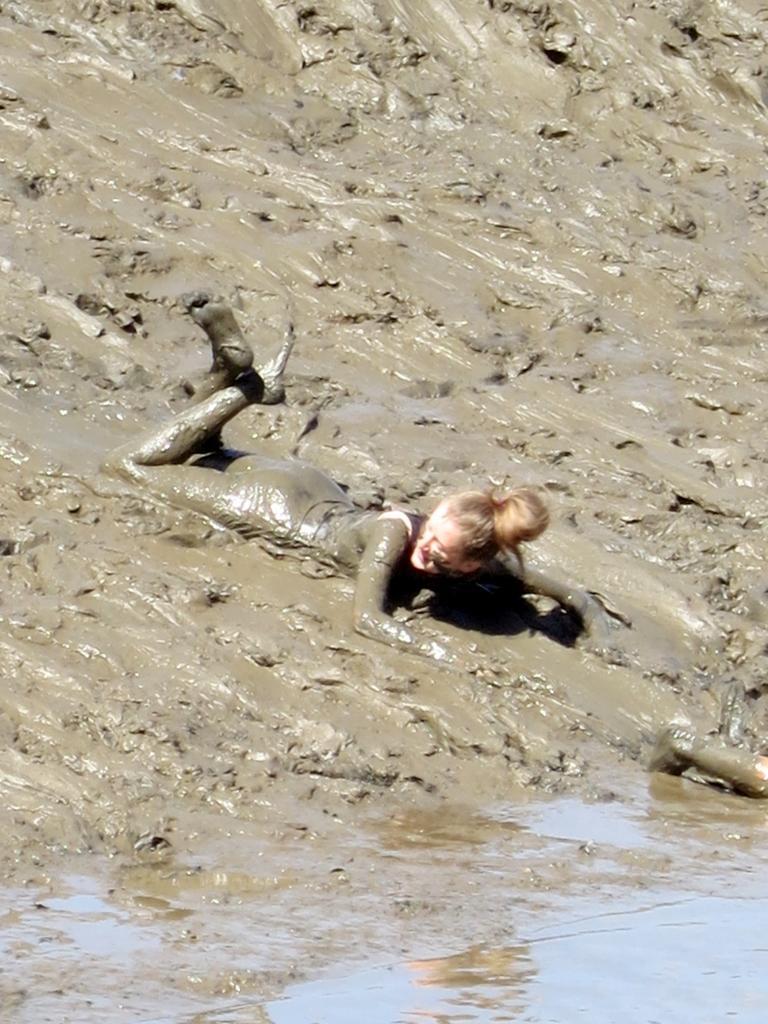How would you summarize this image in a sentence or two? In this image I can see a person visible on mud. 